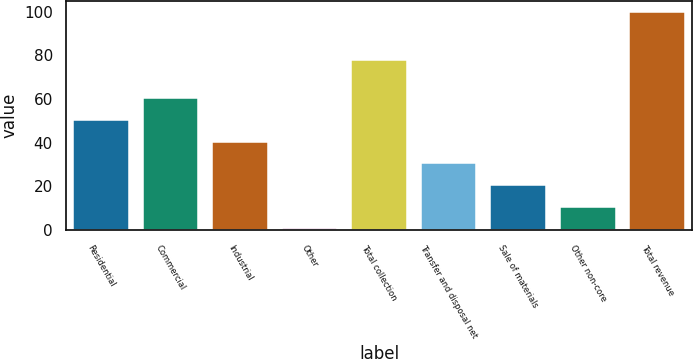Convert chart to OTSL. <chart><loc_0><loc_0><loc_500><loc_500><bar_chart><fcel>Residential<fcel>Commercial<fcel>Industrial<fcel>Other<fcel>Total collection<fcel>Transfer and disposal net<fcel>Sale of materials<fcel>Other non-core<fcel>Total revenue<nl><fcel>50.35<fcel>60.28<fcel>40.42<fcel>0.7<fcel>77.7<fcel>30.49<fcel>20.56<fcel>10.63<fcel>100<nl></chart> 